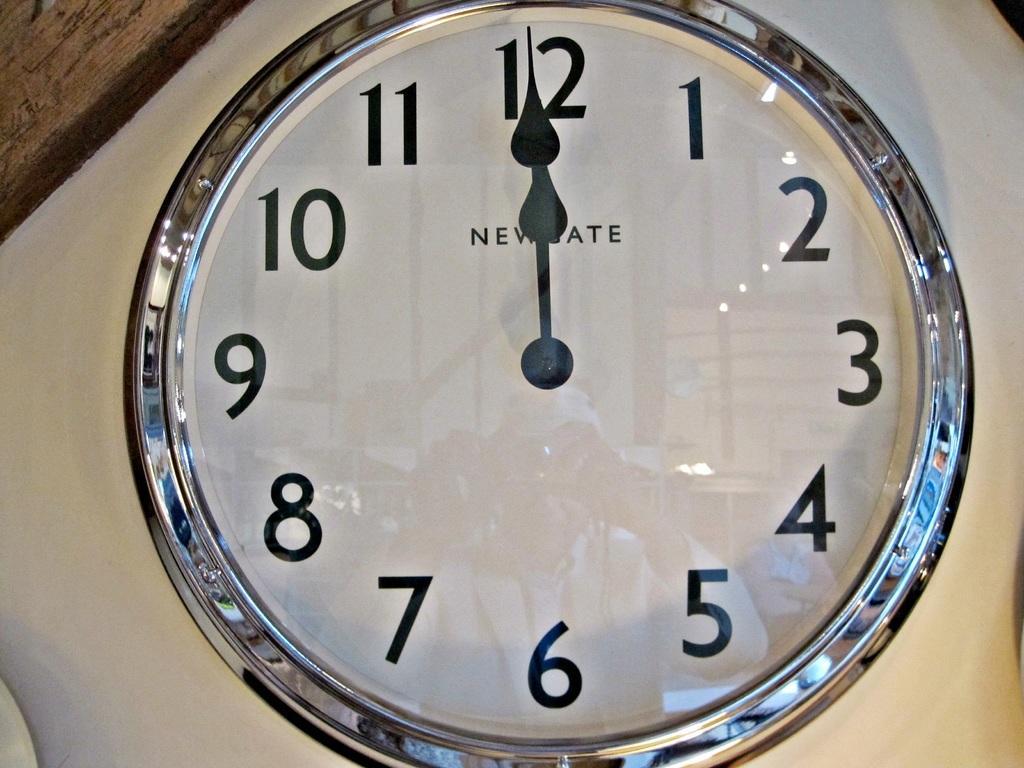In one or two sentences, can you explain what this image depicts? In this picture we can see a clock on a white surface. 